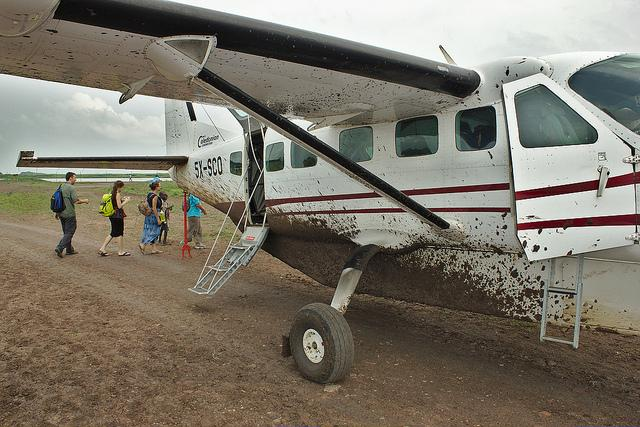What had recently happened when this plane landed prior to this place? rain 